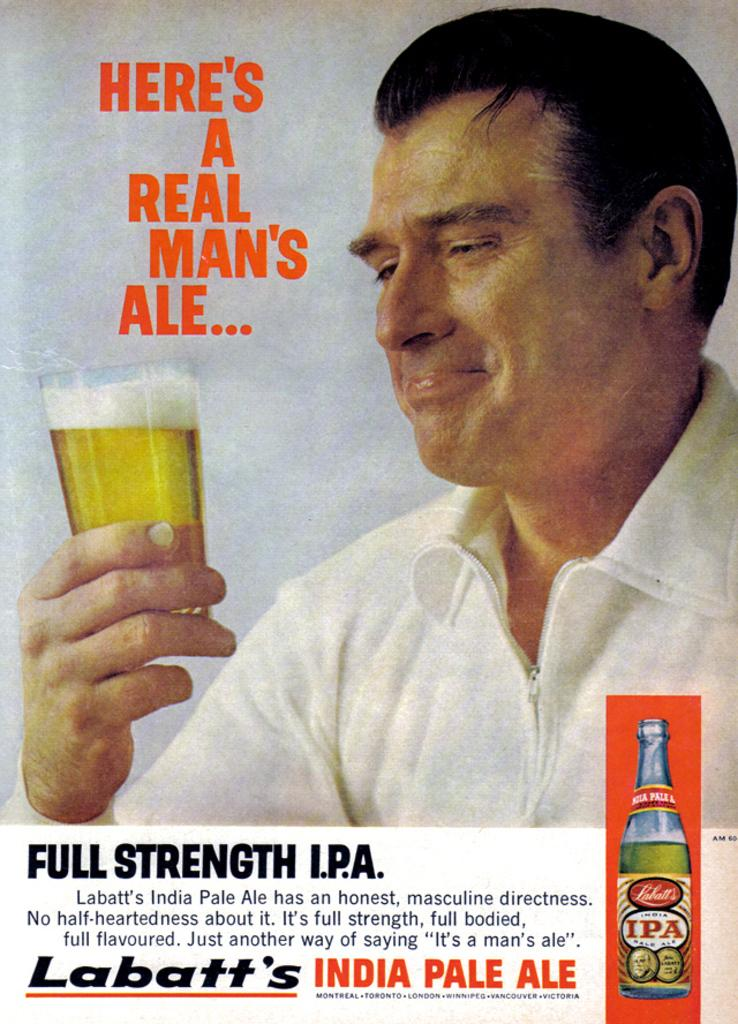What is featured on the poster in the image? There is a poster in the image, and it contains a picture of a person. What is the person in the picture doing? The person in the picture is holding a glass. Is there any text on the poster? Yes, there is text written on the poster. How many police officers are visible in the image? There are no police officers present in the image; it features a poster with a person holding a glass. Are there any mice running around on the poster? There are no mice present on the poster; it features a person holding a glass and text. 